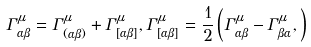Convert formula to latex. <formula><loc_0><loc_0><loc_500><loc_500>\Gamma ^ { \mu } _ { \alpha \beta } = \Gamma ^ { \mu } _ { ( \alpha \beta ) } + \Gamma ^ { \mu } _ { [ \alpha \beta ] } , \Gamma ^ { \mu } _ { [ \alpha \beta ] } = \frac { 1 } { 2 } \left ( \Gamma ^ { \mu } _ { \alpha \beta } - \Gamma ^ { \mu } _ { \beta \alpha } , \right )</formula> 